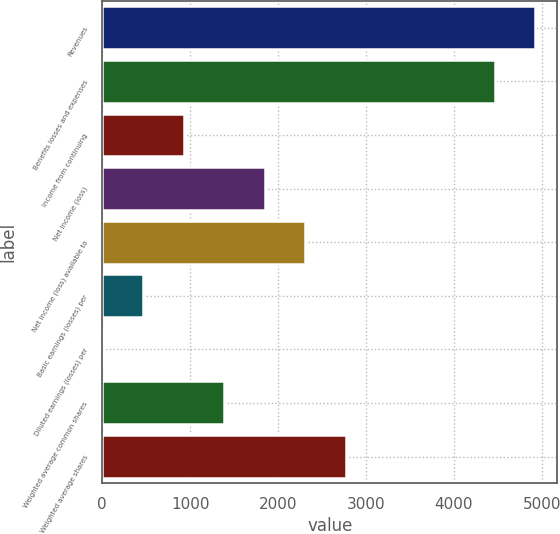Convert chart. <chart><loc_0><loc_0><loc_500><loc_500><bar_chart><fcel>Revenues<fcel>Benefits losses and expenses<fcel>Income from continuing<fcel>Net income (loss)<fcel>Net income (loss) available to<fcel>Basic earnings (losses) per<fcel>Diluted earnings (losses) per<fcel>Weighted average common shares<fcel>Weighted average shares<nl><fcel>4927.5<fcel>4466<fcel>924<fcel>1847<fcel>2308.5<fcel>462.5<fcel>1<fcel>1385.5<fcel>2770<nl></chart> 